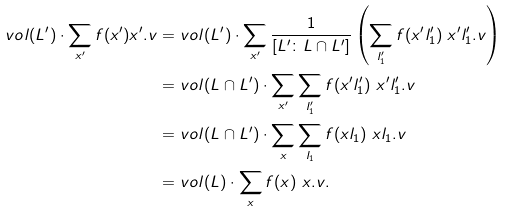<formula> <loc_0><loc_0><loc_500><loc_500>v o l ( L ^ { \prime } ) \cdot \sum _ { x ^ { \prime } } f ( x ^ { \prime } ) x ^ { \prime } . v & = v o l ( L ^ { \prime } ) \cdot \sum _ { x ^ { \prime } } \frac { 1 } { \left [ L ^ { \prime } \colon L \cap L ^ { \prime } \right ] } \left ( \sum _ { l ^ { \prime } _ { 1 } } f ( x ^ { \prime } l ^ { \prime } _ { 1 } ) \ x ^ { \prime } l ^ { \prime } _ { 1 } . v \right ) \\ & = v o l ( L \cap L ^ { \prime } ) \cdot \sum _ { x ^ { \prime } } \sum _ { l ^ { \prime } _ { 1 } } f ( x ^ { \prime } l ^ { \prime } _ { 1 } ) \ x ^ { \prime } l ^ { \prime } _ { 1 } . v \\ & = v o l ( L \cap L ^ { \prime } ) \cdot \sum _ { x } \sum _ { l _ { 1 } } f ( x l _ { 1 } ) \ x l _ { 1 } . v \\ & = v o l ( L ) \cdot \sum _ { x } f ( x ) \ x . v . \\</formula> 